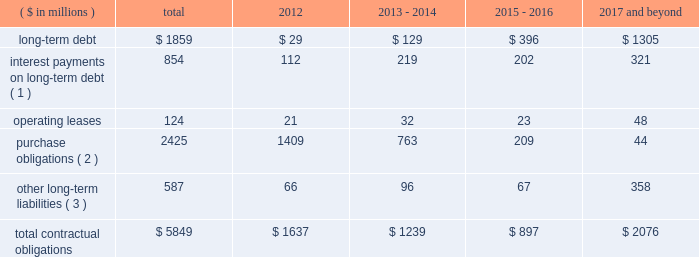Contractual obligations in 2011 , we issued $ 1200 million of senior notes and entered into the credit facility with third-party lenders in the amount of $ 1225 million .
As of december 31 , 2011 , total outstanding long-term debt was $ 1859 million , consisting of these senior notes and the credit facility , in addition to $ 105 million of third party debt that remained outstanding subsequent to the spin-off .
In connection with the spin-off , we entered into a transition services agreement with northrop grumman , under which northrop grumman or certain of its subsidiaries provides us with certain services to help ensure an orderly transition following the distribution .
Under the transition services agreement , northrop grumman provides , for up to 12 months following the spin-off , certain enterprise shared services ( including information technology , resource planning , financial , procurement and human resource services ) , benefits support services and other specified services .
The original term of the transition services agreement ends on march 31 , 2012 , although we have the right to and have cancelled certain services as we transition to new third-party providers .
The services provided by northrop grumman are charged to us at cost , and a limited number of these services may be extended for a period of approximately six months to allow full information systems transition .
See note 20 : related party transactions and former parent company equity in item 8 .
In connection with the spin-off , we entered into a tax matters agreement with northrop grumman ( the 201ctax matters agreement 201d ) that governs the respective rights , responsibilities and obligations of northrop grumman and us after the spin-off with respect to tax liabilities and benefits , tax attributes , tax contests and other tax sharing regarding u.s .
Federal , state , local and foreign income taxes , other taxes and related tax returns .
We have several liabilities with northrop grumman to the irs for the consolidated u.s .
Federal income taxes of the northrop grumman consolidated group relating to the taxable periods in which we were part of that group .
However , the tax matters agreement specifies the portion of this tax liability for which we will bear responsibility , and northrop grumman has agreed to indemnify us against any amounts for which we are not responsible .
The tax matters agreement also provides special rules for allocating tax liabilities in the event that the spin-off , together with certain related transactions , is not tax-free .
See note 20 : related party transactions and former parent company equity in item 8 .
We do not expect either the transition services agreement or the tax matters agreement to have a significant impact on our financial condition and results of operations .
The table presents our contractual obligations as of december 31 , 2011 , and the related estimated timing of future cash payments : ( $ in millions ) total 2012 2013 - 2014 2015 - 2016 2017 and beyond .
( 1 ) interest payments include interest on $ 554 million of variable interest rate debt calculated based on interest rates at december 31 , 2011 .
( 2 ) a 201cpurchase obligation 201d is defined as an agreement to purchase goods or services that is enforceable and legally binding on us and that specifies all significant terms , including : fixed or minimum quantities to be purchased ; fixed , minimum , or variable price provisions ; and the approximate timing of the transaction .
These amounts are primarily comprised of open purchase order commitments to vendors and subcontractors pertaining to funded contracts .
( 3 ) other long-term liabilities primarily consist of total accrued workers 2019 compensation reserves , deferred compensation , and other miscellaneous liabilities , of which $ 201 million is the current portion of workers 2019 compensation liabilities .
It excludes obligations for uncertain tax positions of $ 9 million , as the timing of the payments , if any , cannot be reasonably estimated .
The above table excludes retirement related contributions .
In 2012 , we expect to make minimum and discretionary contributions to our qualified pension plans of approximately $ 153 million and $ 65 million , respectively , exclusive of any u.s .
Government recoveries .
We will continue to periodically evaluate whether to make additional discretionary contributions .
In 2012 , we expect to make $ 35 million in contributions for our other postretirement plans , exclusive of any .
What portion of the long-term debt is included in the section of current liabilities on the balance sheet as of december 31 , 2011? 
Computations: (29 / 1859)
Answer: 0.0156. 